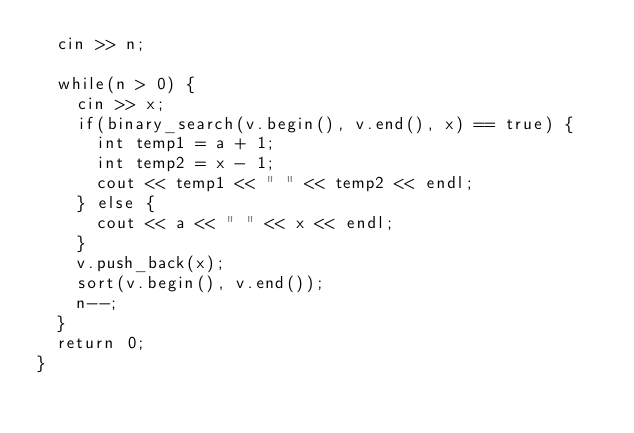<code> <loc_0><loc_0><loc_500><loc_500><_C++_>  cin >> n;

  while(n > 0) {
    cin >> x;
    if(binary_search(v.begin(), v.end(), x) == true) {
      int temp1 = a + 1;
      int temp2 = x - 1;
      cout << temp1 << " " << temp2 << endl;
    } else {
      cout << a << " " << x << endl;
    }
    v.push_back(x);
    sort(v.begin(), v.end());
    n--;
  }
  return 0;
}
</code> 